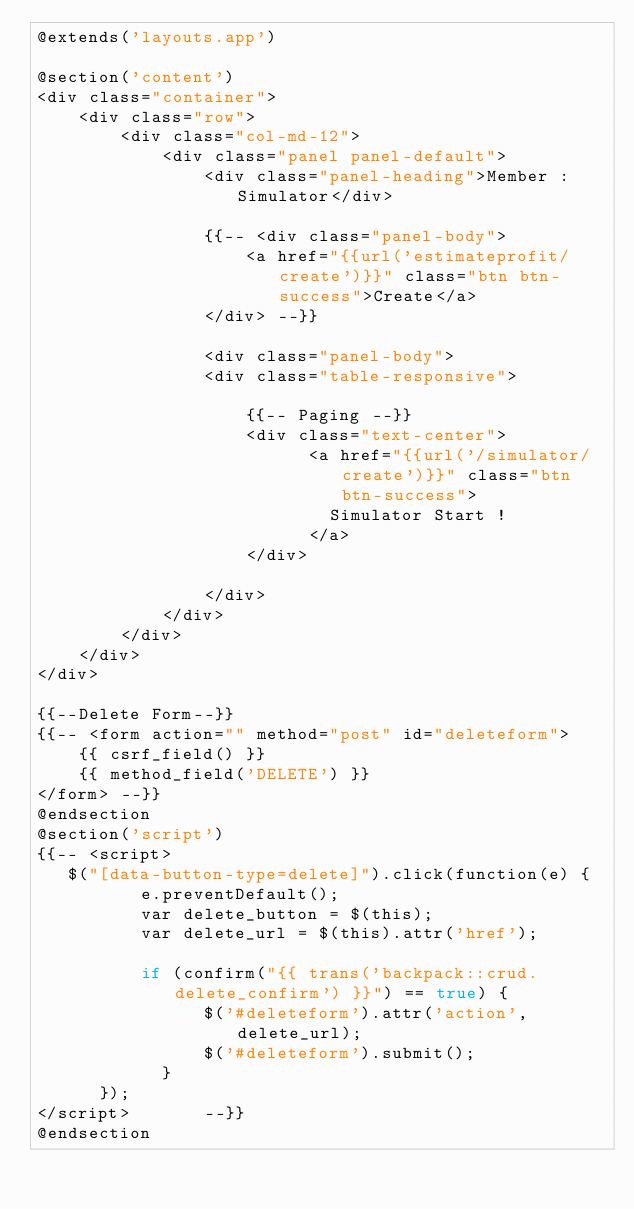Convert code to text. <code><loc_0><loc_0><loc_500><loc_500><_PHP_>@extends('layouts.app')

@section('content')
<div class="container">
    <div class="row">
        <div class="col-md-12">
            <div class="panel panel-default">
                <div class="panel-heading">Member : Simulator</div> 
                
                {{-- <div class="panel-body">
                    <a href="{{url('estimateprofit/create')}}" class="btn btn-success">Create</a>
                </div> --}}

                <div class="panel-body">  
                <div class="table-responsive">
                    
                    {{-- Paging --}}
                    <div class="text-center">
                          <a href="{{url('/simulator/create')}}" class="btn btn-success">
                            Simulator Start !
                          </a>
                    </div>

                </div>
            </div>
        </div>
    </div>
</div>

{{--Delete Form--}}
{{-- <form action="" method="post" id="deleteform">
    {{ csrf_field() }}
    {{ method_field('DELETE') }}
</form> --}}
@endsection
@section('script')
{{-- <script>
   $("[data-button-type=delete]").click(function(e) {
          e.preventDefault();
          var delete_button = $(this);
          var delete_url = $(this).attr('href');

          if (confirm("{{ trans('backpack::crud.delete_confirm') }}") == true) {
                $('#deleteform').attr('action',delete_url);
                $('#deleteform').submit();
            }
      }); 
</script>       --}}
@endsection</code> 